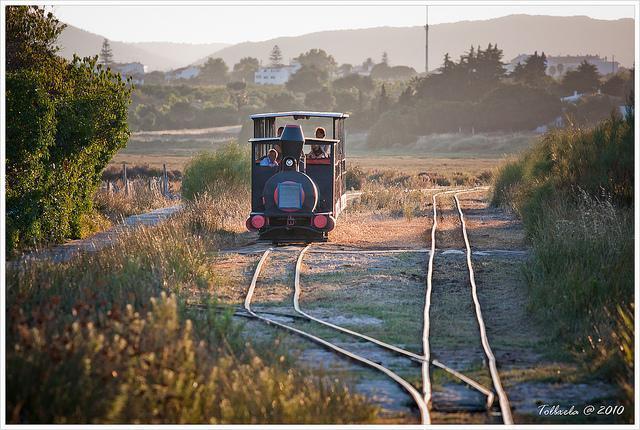How many people are on the train?
Give a very brief answer. 3. How many motor vehicles have orange paint?
Give a very brief answer. 0. 